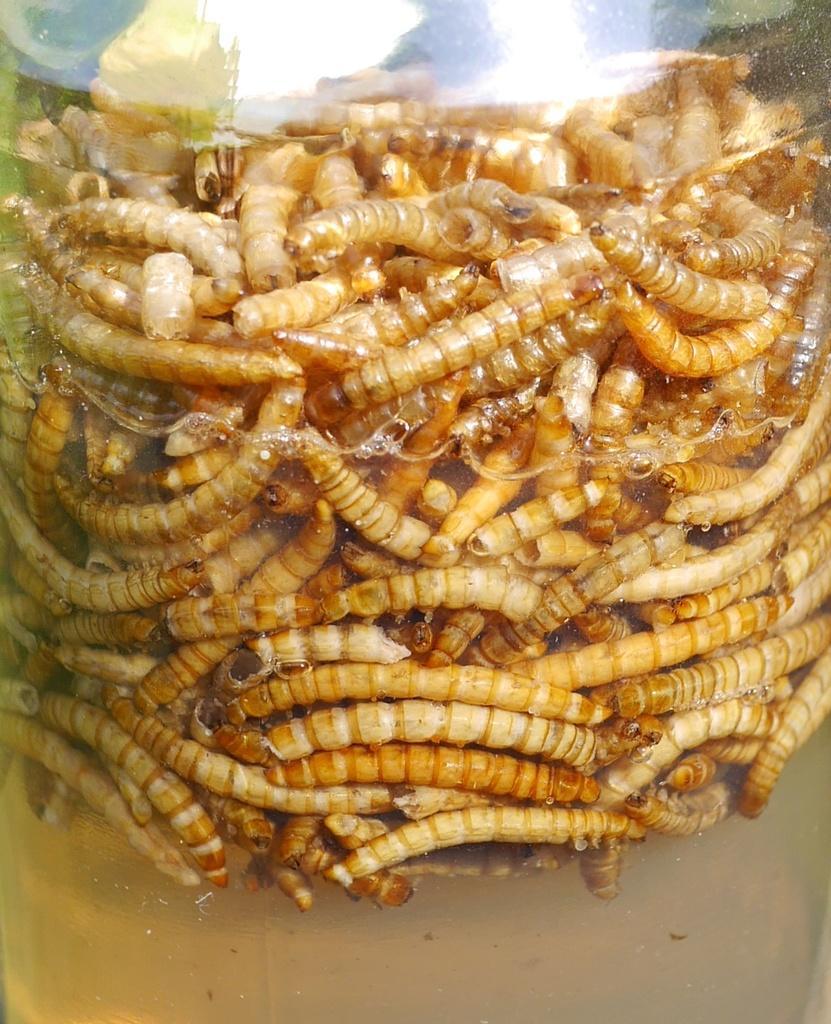How would you summarize this image in a sentence or two? In this picture I can see so many insects and a type of liquid in a glass item. 